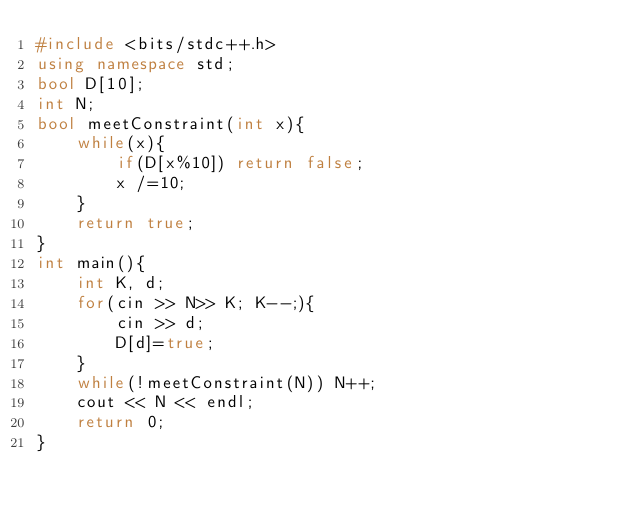Convert code to text. <code><loc_0><loc_0><loc_500><loc_500><_C++_>#include <bits/stdc++.h>
using namespace std;
bool D[10];
int N;
bool meetConstraint(int x){
    while(x){
        if(D[x%10]) return false;
        x /=10;
    }
    return true;
}
int main(){
    int K, d;
    for(cin >> N>> K; K--;){
        cin >> d;
        D[d]=true;
    }
    while(!meetConstraint(N)) N++;
    cout << N << endl;
    return 0;
}</code> 